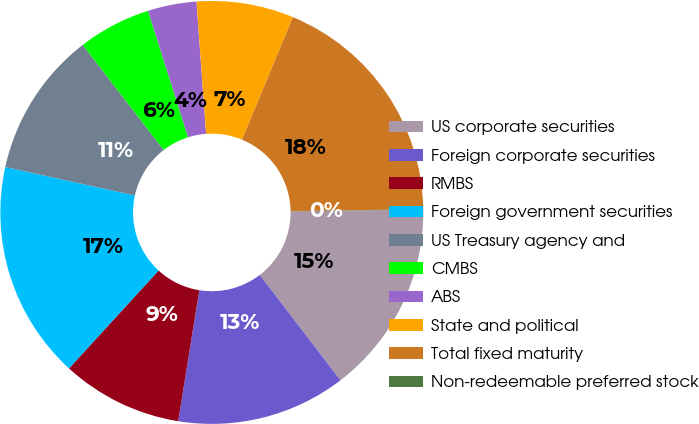<chart> <loc_0><loc_0><loc_500><loc_500><pie_chart><fcel>US corporate securities<fcel>Foreign corporate securities<fcel>RMBS<fcel>Foreign government securities<fcel>US Treasury agency and<fcel>CMBS<fcel>ABS<fcel>State and political<fcel>Total fixed maturity<fcel>Non-redeemable preferred stock<nl><fcel>14.8%<fcel>12.95%<fcel>9.26%<fcel>16.64%<fcel>11.11%<fcel>5.57%<fcel>3.72%<fcel>7.42%<fcel>18.49%<fcel>0.03%<nl></chart> 